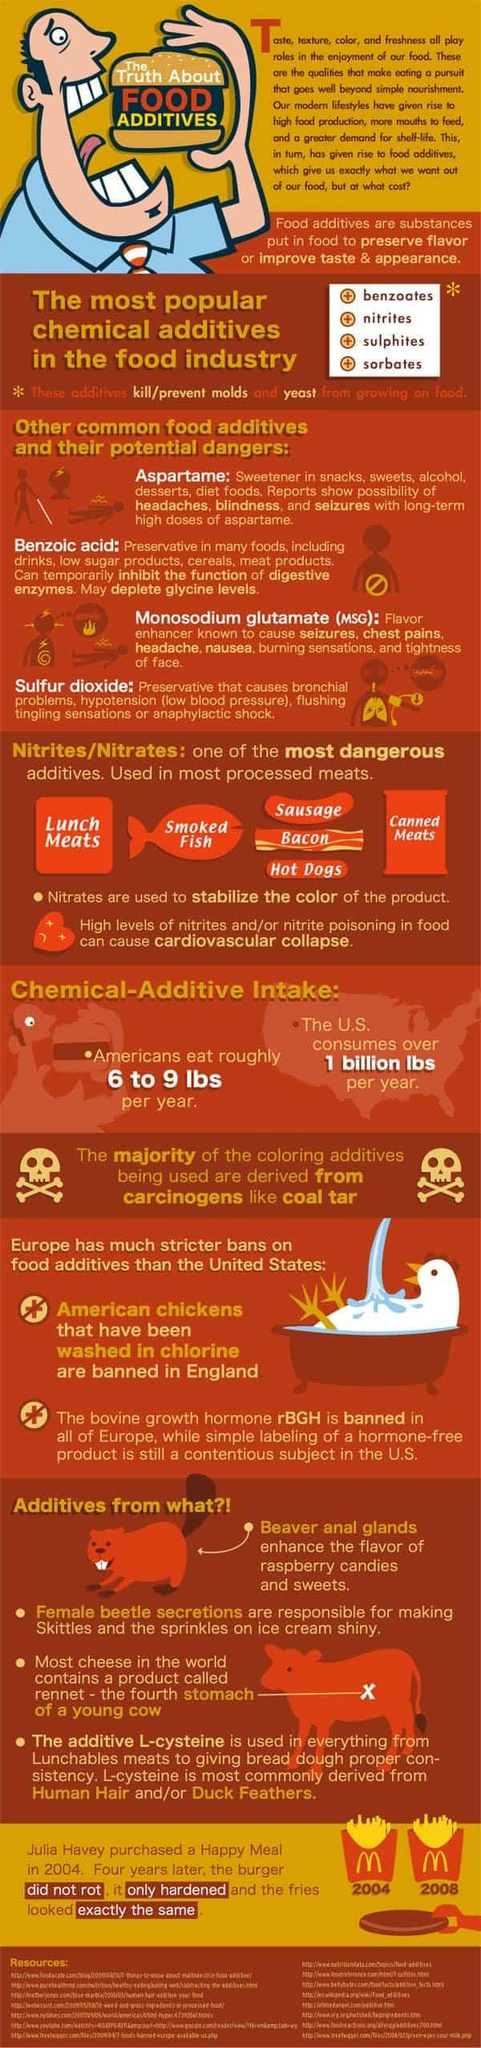Which additive causes chest pain-benzoic acid or msg?
Answer the question with a short phrase. msg What is the name of the additive used in canned meats? Nitrites/Nitrates Which additive causes blindness-msg or aspartame? aspartame In which food item aspartame is used-cereals or alcohol? alcohol What is the name of the additive used in smoked fish? Nitrites/Nitrates In which food item benzoic acid is used-snacks or drinks? drinks 